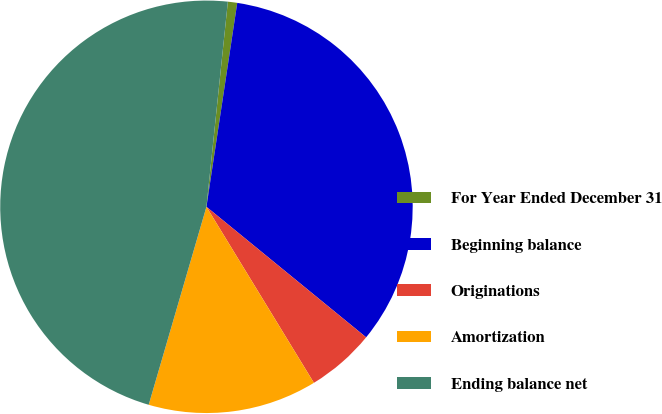Convert chart to OTSL. <chart><loc_0><loc_0><loc_500><loc_500><pie_chart><fcel>For Year Ended December 31<fcel>Beginning balance<fcel>Originations<fcel>Amortization<fcel>Ending balance net<nl><fcel>0.73%<fcel>33.52%<fcel>5.37%<fcel>13.24%<fcel>47.14%<nl></chart> 